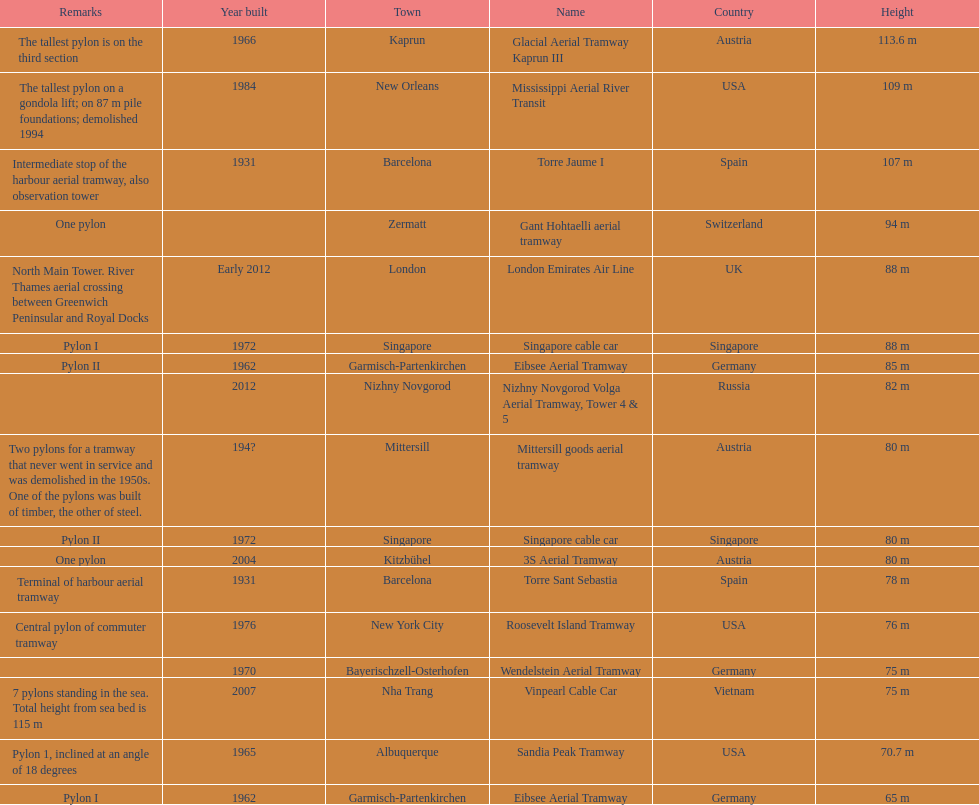What year was the last pylon in germany built? 1970. 